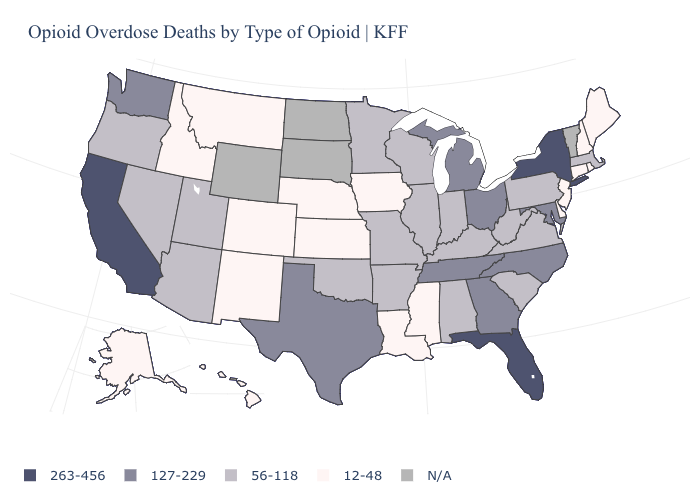Does Hawaii have the lowest value in the USA?
Give a very brief answer. Yes. Name the states that have a value in the range 12-48?
Short answer required. Alaska, Colorado, Connecticut, Delaware, Hawaii, Idaho, Iowa, Kansas, Louisiana, Maine, Mississippi, Montana, Nebraska, New Hampshire, New Jersey, New Mexico, Rhode Island. What is the highest value in the USA?
Concise answer only. 263-456. Among the states that border Oregon , which have the lowest value?
Concise answer only. Idaho. What is the value of New Jersey?
Give a very brief answer. 12-48. Does the map have missing data?
Quick response, please. Yes. Among the states that border Indiana , which have the highest value?
Give a very brief answer. Michigan, Ohio. Does the first symbol in the legend represent the smallest category?
Give a very brief answer. No. What is the highest value in the USA?
Short answer required. 263-456. Name the states that have a value in the range N/A?
Quick response, please. North Dakota, South Dakota, Vermont, Wyoming. What is the value of South Carolina?
Short answer required. 56-118. Name the states that have a value in the range 263-456?
Answer briefly. California, Florida, New York. What is the value of Utah?
Keep it brief. 56-118. What is the value of Florida?
Be succinct. 263-456. Does Minnesota have the highest value in the USA?
Concise answer only. No. 